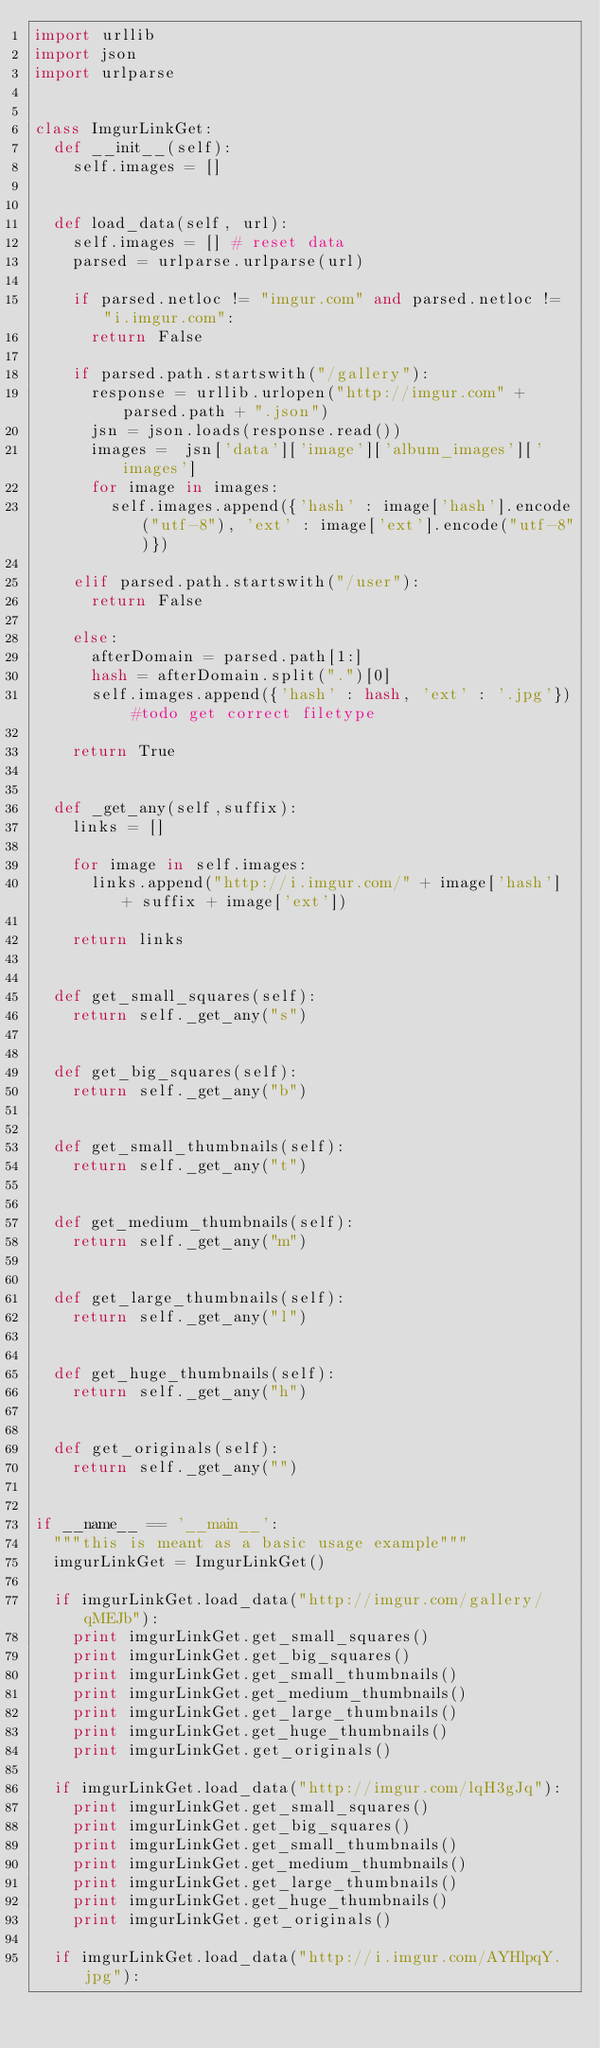Convert code to text. <code><loc_0><loc_0><loc_500><loc_500><_Python_>import urllib
import json
import urlparse


class ImgurLinkGet:
	def __init__(self):
		self.images = []


	def load_data(self, url):
		self.images = [] # reset data
		parsed = urlparse.urlparse(url)

		if parsed.netloc != "imgur.com" and parsed.netloc != "i.imgur.com":
			return False

		if parsed.path.startswith("/gallery"):
			response = urllib.urlopen("http://imgur.com" + parsed.path + ".json")
			jsn = json.loads(response.read())
			images =  jsn['data']['image']['album_images']['images']
			for image in images:
				self.images.append({'hash' : image['hash'].encode("utf-8"), 'ext' : image['ext'].encode("utf-8")})

		elif parsed.path.startswith("/user"):
			return False

		else:
			afterDomain = parsed.path[1:]
			hash = afterDomain.split(".")[0]
			self.images.append({'hash' : hash, 'ext' : '.jpg'}) #todo get correct filetype

		return True


	def _get_any(self,suffix):
		links = []

		for image in self.images:
			links.append("http://i.imgur.com/" + image['hash'] + suffix + image['ext'])

		return links


	def get_small_squares(self):
		return self._get_any("s")


	def get_big_squares(self):
		return self._get_any("b")


	def get_small_thumbnails(self):
		return self._get_any("t")


	def get_medium_thumbnails(self):
		return self._get_any("m")


	def get_large_thumbnails(self):
		return self._get_any("l")


	def get_huge_thumbnails(self):
		return self._get_any("h")


	def get_originals(self):
		return self._get_any("")


if __name__ == '__main__':
	"""this is meant as a basic usage example"""
	imgurLinkGet = ImgurLinkGet()

	if imgurLinkGet.load_data("http://imgur.com/gallery/qMEJb"):
		print imgurLinkGet.get_small_squares()
		print imgurLinkGet.get_big_squares()
		print imgurLinkGet.get_small_thumbnails()
		print imgurLinkGet.get_medium_thumbnails()
		print imgurLinkGet.get_large_thumbnails()
		print imgurLinkGet.get_huge_thumbnails()
		print imgurLinkGet.get_originals()

	if imgurLinkGet.load_data("http://imgur.com/lqH3gJq"):
		print imgurLinkGet.get_small_squares()
		print imgurLinkGet.get_big_squares()
		print imgurLinkGet.get_small_thumbnails()
		print imgurLinkGet.get_medium_thumbnails()
		print imgurLinkGet.get_large_thumbnails()
		print imgurLinkGet.get_huge_thumbnails()
		print imgurLinkGet.get_originals()

	if imgurLinkGet.load_data("http://i.imgur.com/AYHlpqY.jpg"):</code> 